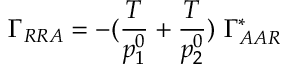Convert formula to latex. <formula><loc_0><loc_0><loc_500><loc_500>\Gamma _ { R R A } = - ( { \frac { T } { p _ { 1 } ^ { 0 } } } + { \frac { T } { p _ { 2 } ^ { 0 } } } ) \ \Gamma _ { A A R } ^ { * }</formula> 